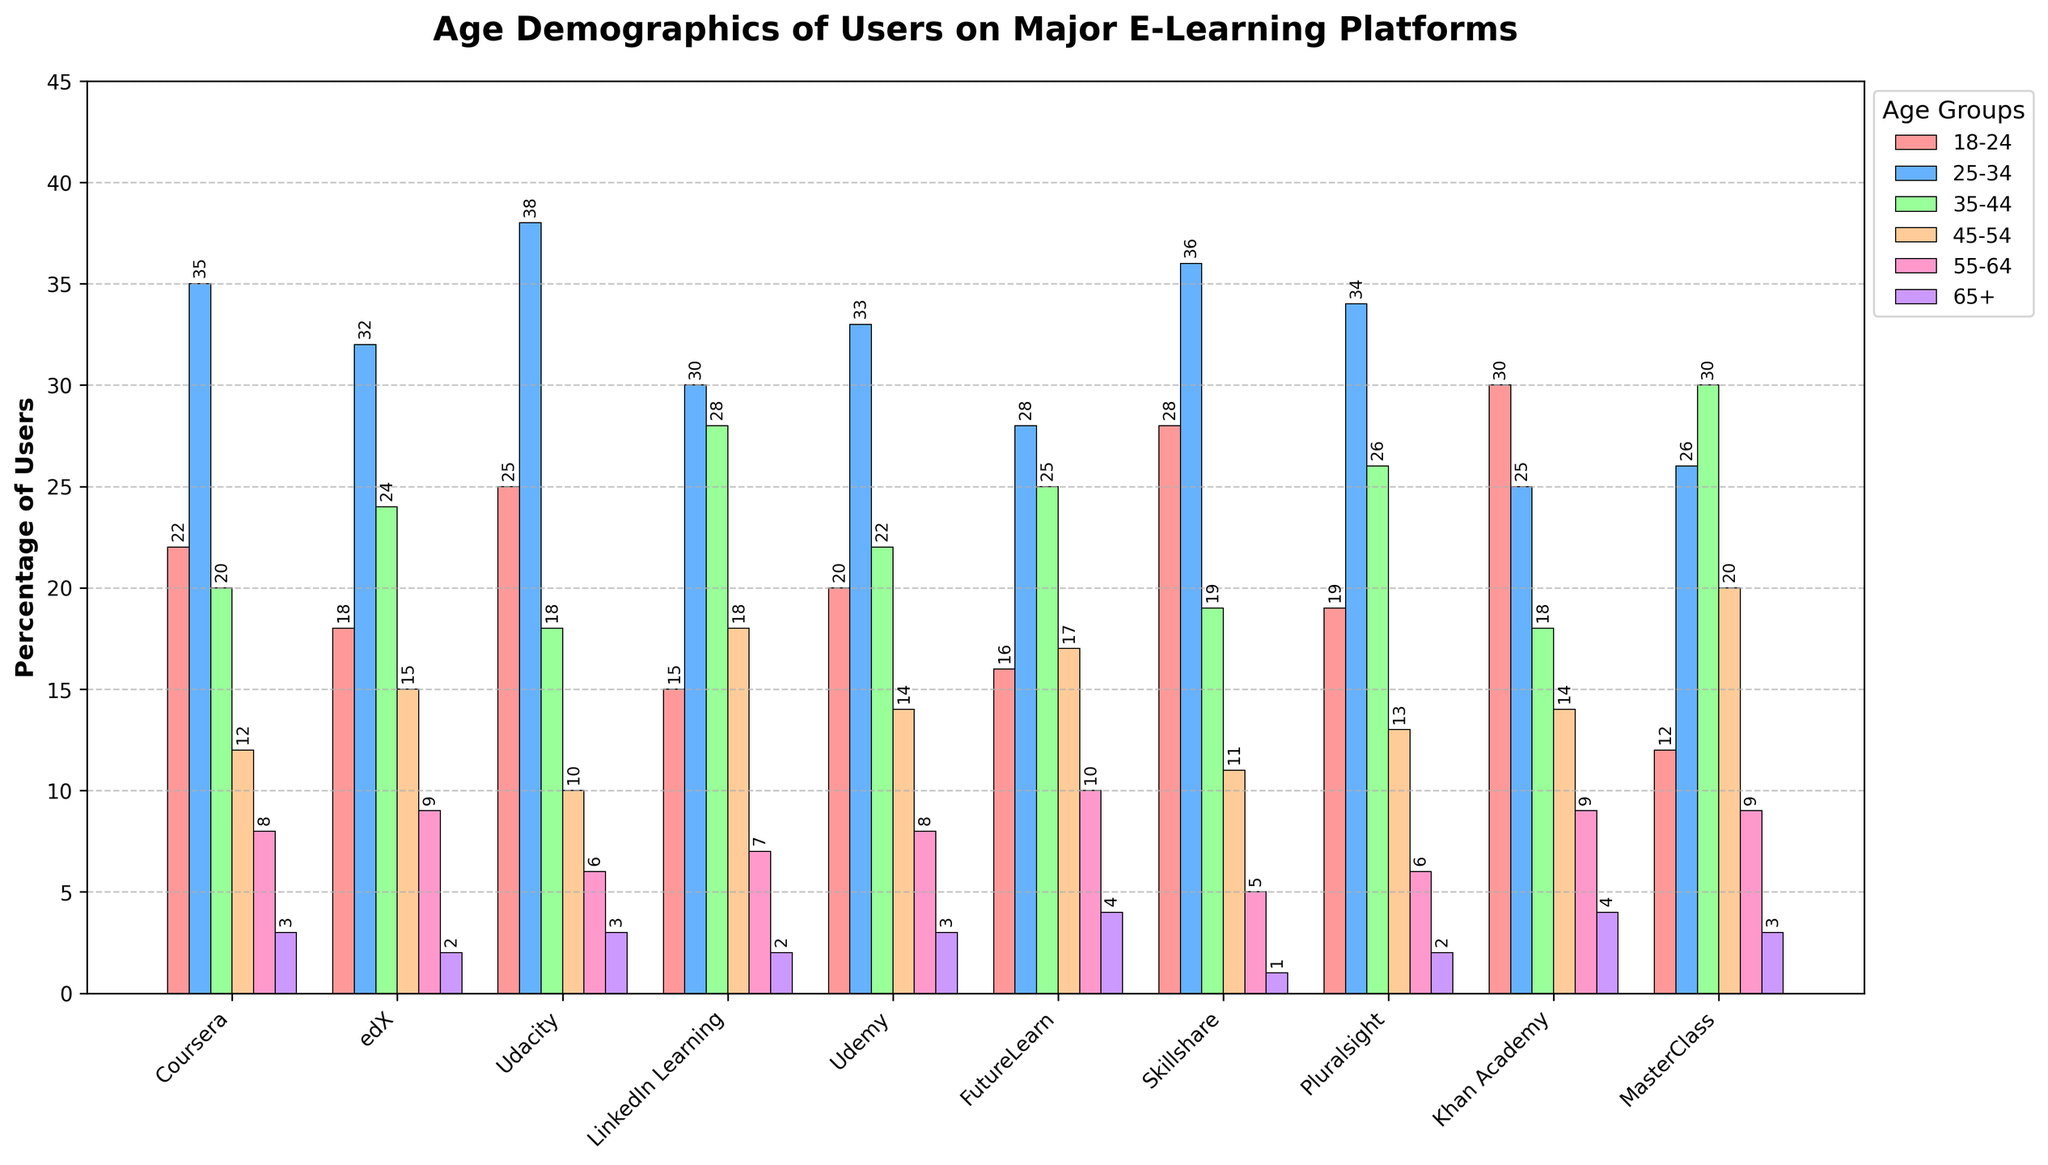What age group has the highest percentage of users on Udacity? To find the age group with the highest percentage on Udacity, look for the tallest bar within the perimeter representing Udacity on the x-axis. The tallest bar for Udacity corresponds to the 25-34 age group.
Answer: 25-34 Which platform has the greatest percentage of users in the 45-54 age group? Check the height of the bars representing the 45-54 age group across all platforms. The tallest bar in this age group is for MasterClass.
Answer: MasterClass What is the total percentage of users aged 18-24 and 65+ on Pluralsight? Identify the two bars representing the 18-24 and 65+ age groups on Pluralsight and sum their percentages—Pluralsight has 19% for 18-24 and 2% for 65+. Adding these, 19 + 2 = 21%.
Answer: 21% Which platform has the smallest percentage of users aged 55-64? Compare the height of the bars representing the 55-64 age group across all platforms. The smallest bar is for Skillshare, which has the lowest percentage.
Answer: Skillshare Among the given platforms, which has a higher percentage of users aged 35-44: FutureLearn or LinkedIn Learning? Compare the height of the bars representing the 35-44 age group for both FutureLearn and LinkedIn Learning. FutureLearn's bar is lower at 25%, while LinkedIn Learning is at 28%.
Answer: LinkedIn Learning What is the difference in user percentage between the 18-24 and 65+ age groups on Khan Academy? Identify the 18-24 and 65+ age groups' percentages for Khan Academy—30% and 4%, respectively. Subtract the 65+ percentage from the 18-24 percentage: 30 - 4 = 26.
Answer: 26 Which age group has the most evenly distributed percentage of users across all platforms? Review the height of bars representing each age group across all platforms. The 25-34 age group consistently has similar heights, indicating an even distribution.
Answer: 25-34 Is the percentage of users aged 45-54 on edX greater or smaller than those aged 35-44 on MasterClass? Compare the bars for users aged 45-54 on edX (15%) and users aged 35-44 on MasterClass (30%). The percentage on edX is smaller.
Answer: Smaller What is the combined percentage of users aged 25-34 on Coursera, edX, and Udacity? Sum the percentages of the 25-34 age group for Coursera (35%), edX (32%), and Udacity (38%). Adding these, 35 + 32 + 38 = 105%.
Answer: 105% Which platform has the highest combined user percentage across the three youngest age groups (18-24, 25-34, 35-44)? Calculate the sum of the percentages for the 18-24, 25-34, and 35-44 age groups for each platform and identify the highest. Skillshare has the highest total: 28% + 36% + 19% = 83%.
Answer: Skillshare 